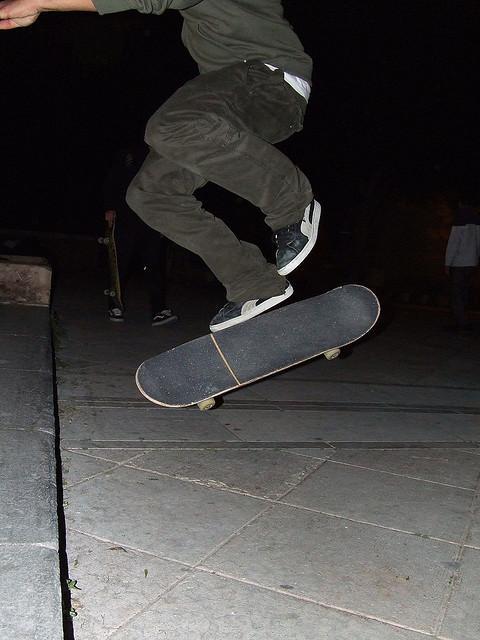How many steps are visible?
Give a very brief answer. 0. How many people are there?
Give a very brief answer. 2. How many decks does the bus have?
Give a very brief answer. 0. 